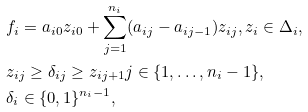<formula> <loc_0><loc_0><loc_500><loc_500>& f _ { i } = a _ { i 0 } z _ { i 0 } + \sum _ { j = 1 } ^ { n _ { i } } ( a _ { i j } - a _ { i j - 1 } ) z _ { i j } , z _ { i } \in \Delta _ { i } , \\ & z _ { i j } \geq \delta _ { i j } \geq z _ { i j + 1 } j \in \{ 1 , \dots , n _ { i } - 1 \} , \\ & \delta _ { i } \in \{ 0 , 1 \} ^ { n _ { i } - 1 } ,</formula> 